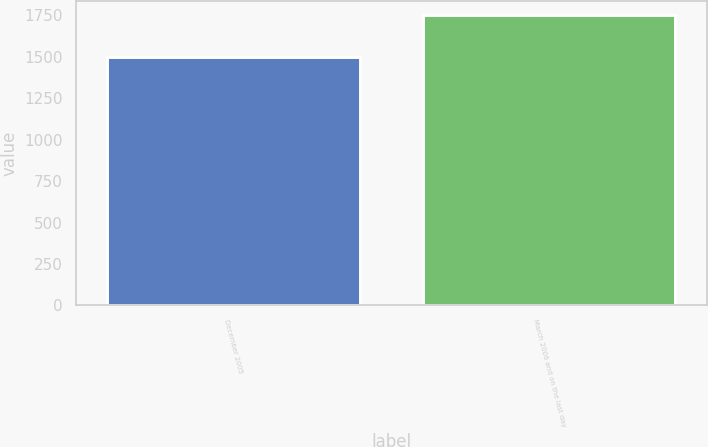Convert chart. <chart><loc_0><loc_0><loc_500><loc_500><bar_chart><fcel>December 2005<fcel>March 2006 and on the last day<nl><fcel>1500<fcel>1750<nl></chart> 